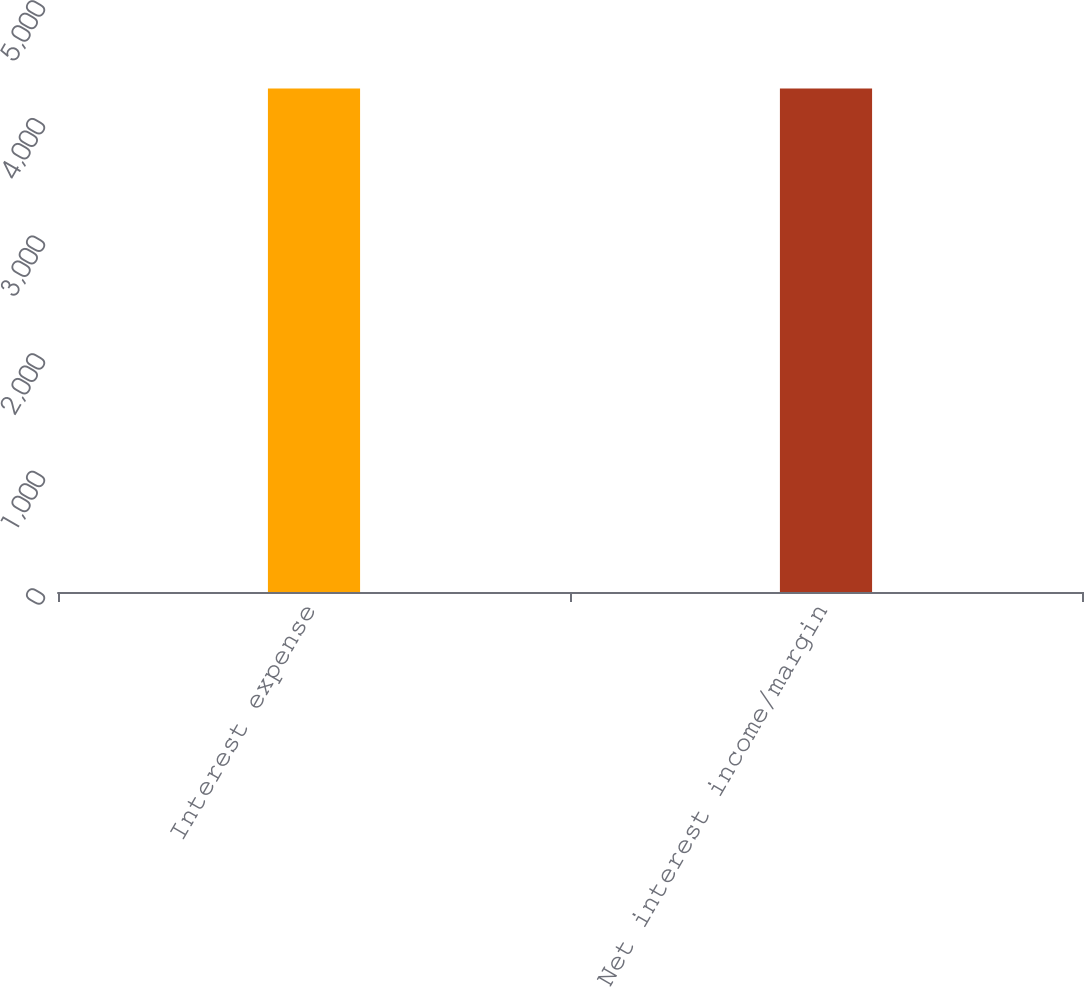Convert chart to OTSL. <chart><loc_0><loc_0><loc_500><loc_500><bar_chart><fcel>Interest expense<fcel>Net interest income/margin<nl><fcel>4281<fcel>4281.1<nl></chart> 